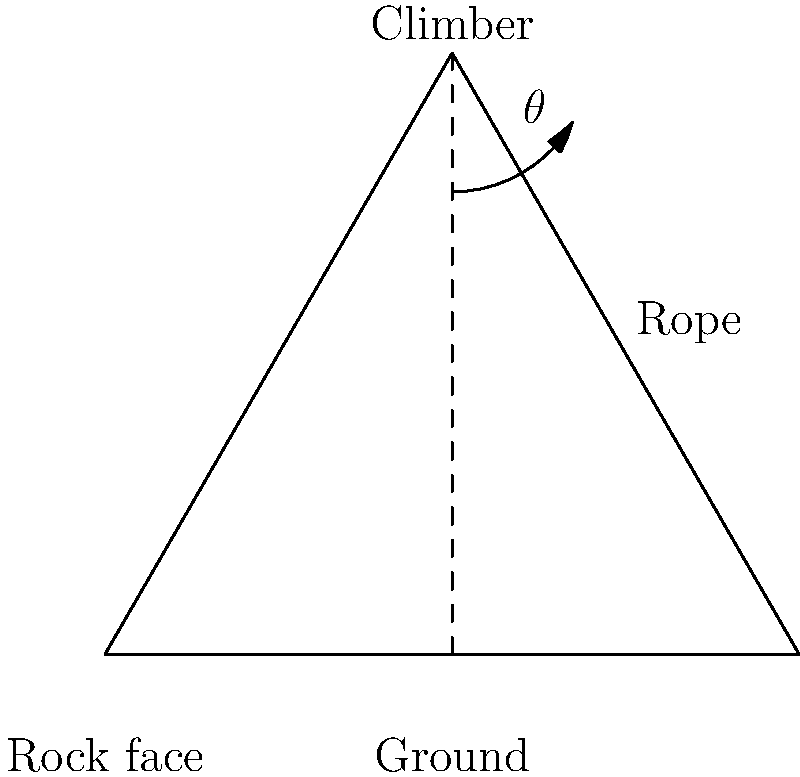As a climbing guide, what is the optimal angle $\theta$ between the climber's rope and the rock face to ensure maximum safety during a potential fall? To determine the optimal angle for fall protection, we need to consider the forces involved:

1. When a climber falls, the rope exerts a force to stop the fall.
2. This force can be decomposed into two components: one parallel to the rock face and one perpendicular to it.
3. The perpendicular component helps to pull the climber away from the rock face, reducing the risk of impact.
4. The parallel component slows the fall.

To maximize safety:
1. We want to maximize the perpendicular component to keep the climber away from the rock.
2. We also need a sufficient parallel component to arrest the fall.
3. The optimal balance is achieved when these components are equal.
4. This occurs when the angle between the rope and the rock face is 45°.

At a 45° angle:
- The perpendicular and parallel components are equal.
- This provides the best combination of fall arrest and rock face clearance.
- It minimizes the total force required to stop the fall while maximizing safety.

Note: In practice, the exact angle may vary slightly depending on factors like rock face texture and climbing gear, but 45° is generally considered optimal.
Answer: 45° 